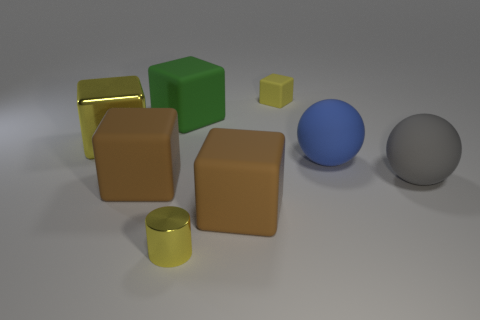Do the large metal thing and the tiny rubber thing have the same color?
Your answer should be compact. Yes. What is the color of the large metallic cube?
Your answer should be compact. Yellow. Does the large gray thing have the same material as the small yellow thing that is in front of the large yellow metal cube?
Ensure brevity in your answer.  No. There is a large rubber thing that is both behind the large gray thing and right of the small yellow metal cylinder; what shape is it?
Your answer should be very brief. Sphere. What number of other things are there of the same color as the shiny cylinder?
Keep it short and to the point. 2. What is the shape of the green rubber thing?
Your response must be concise. Cube. The metallic object behind the small metal thing that is to the left of the gray rubber thing is what color?
Provide a succinct answer. Yellow. Is the color of the small rubber cube the same as the metal thing that is behind the cylinder?
Provide a succinct answer. Yes. There is a yellow thing that is both behind the gray matte sphere and to the right of the big yellow metallic block; what is it made of?
Your answer should be very brief. Rubber. Is there a gray shiny cube of the same size as the green matte cube?
Make the answer very short. No. 